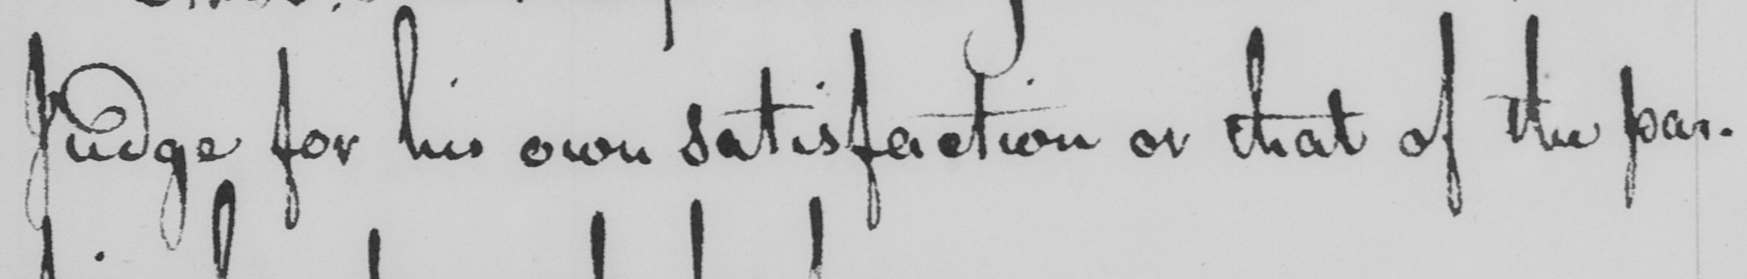What does this handwritten line say? Judge for his own satisfaction or that of the par- 